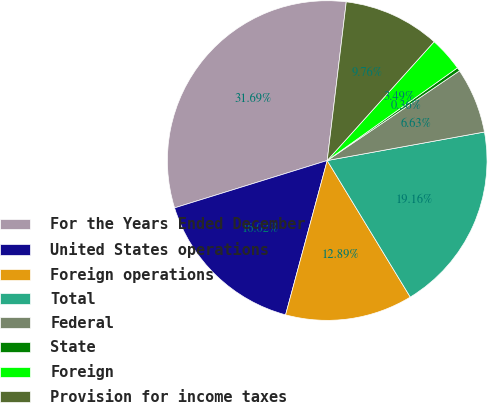Convert chart to OTSL. <chart><loc_0><loc_0><loc_500><loc_500><pie_chart><fcel>For the Years Ended December<fcel>United States operations<fcel>Foreign operations<fcel>Total<fcel>Federal<fcel>State<fcel>Foreign<fcel>Provision for income taxes<nl><fcel>31.69%<fcel>16.02%<fcel>12.89%<fcel>19.16%<fcel>6.63%<fcel>0.36%<fcel>3.49%<fcel>9.76%<nl></chart> 